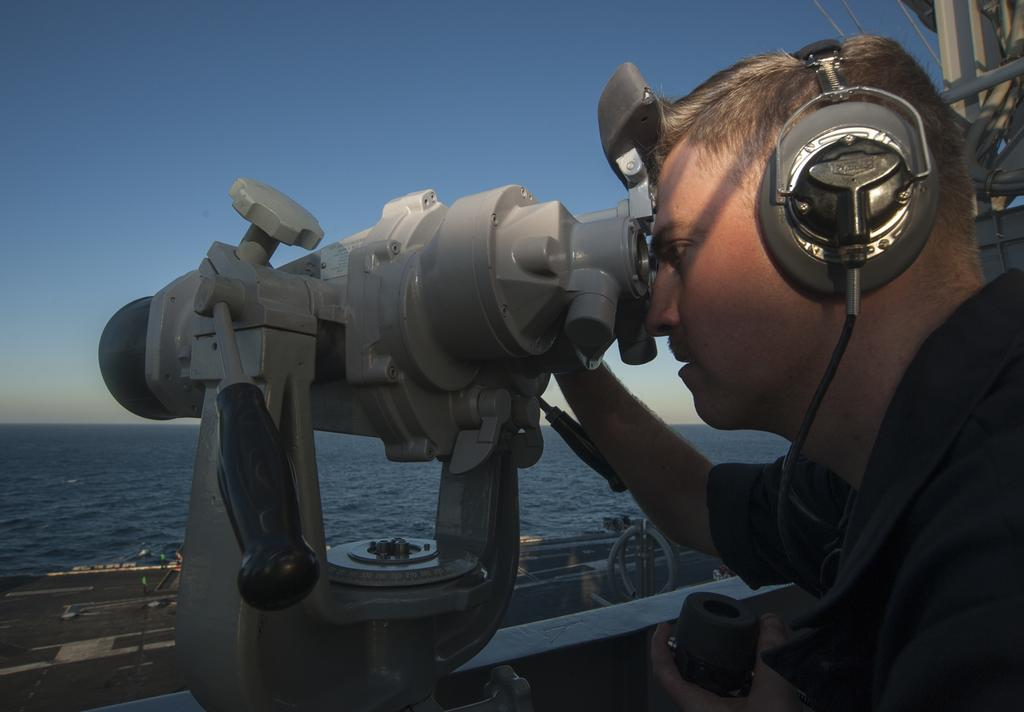Who is present in the image? There is a person in the image. What is the person holding in the image? The person is holding binoculars. What else is the person wearing in the image? The person is wearing a headset. What can be seen in the background of the image? There is sea visible in the background of the image. What is visible at the top of the image? The sky is visible at the top of the image. What type of idea can be seen in the image? There is no idea present in the image; it features a person holding binoculars and wearing a headset, with sea and sky visible in the background. How many ants can be seen crawling on the person's headset in the image? There are no ants present in the image. 